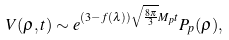Convert formula to latex. <formula><loc_0><loc_0><loc_500><loc_500>V ( \rho , t ) \sim e ^ { ( 3 - f ( \lambda ) ) \sqrt { \frac { 8 \pi } { 3 } } M _ { p } t } P _ { p } ( \rho ) ,</formula> 